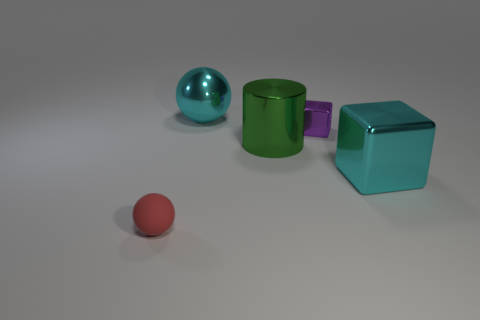What size is the object that is the same color as the large shiny cube?
Provide a succinct answer. Large. What number of big things are gray shiny blocks or red matte balls?
Provide a short and direct response. 0. What number of spheres are there?
Your answer should be very brief. 2. Are there the same number of big green metal objects that are in front of the green object and red balls left of the large cube?
Offer a terse response. No. Are there any metal cylinders to the right of the tiny purple shiny block?
Your response must be concise. No. What is the color of the sphere behind the small block?
Your answer should be compact. Cyan. There is a cube that is on the left side of the metal block on the right side of the purple shiny cube; what is its material?
Provide a succinct answer. Metal. Is the number of big cyan objects that are behind the large cyan metal cube less than the number of spheres that are in front of the green cylinder?
Your answer should be very brief. No. How many blue things are big shiny cylinders or small metal spheres?
Provide a succinct answer. 0. Are there an equal number of red matte objects to the right of the matte sphere and balls?
Your answer should be compact. No. 